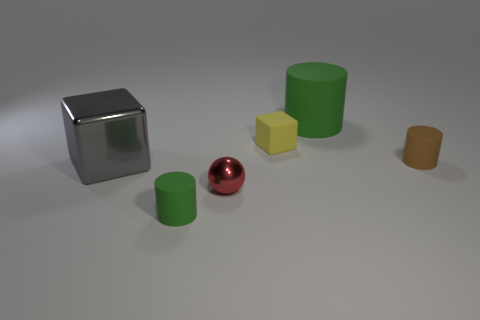How many purple objects are either large blocks or tiny matte blocks?
Provide a succinct answer. 0. What number of cubes have the same size as the sphere?
Provide a succinct answer. 1. The tiny thing that is behind the tiny green matte cylinder and in front of the gray block is what color?
Keep it short and to the point. Red. Are there more small metal things that are in front of the yellow rubber cube than brown metallic objects?
Ensure brevity in your answer.  Yes. Are there any small cyan things?
Your response must be concise. No. How many large things are either red rubber cylinders or yellow things?
Your response must be concise. 0. Is there anything else of the same color as the tiny metallic thing?
Ensure brevity in your answer.  No. What shape is the tiny yellow thing that is made of the same material as the small brown cylinder?
Your answer should be very brief. Cube. There is a cube that is right of the sphere; what size is it?
Make the answer very short. Small. There is a yellow rubber thing; what shape is it?
Give a very brief answer. Cube. 